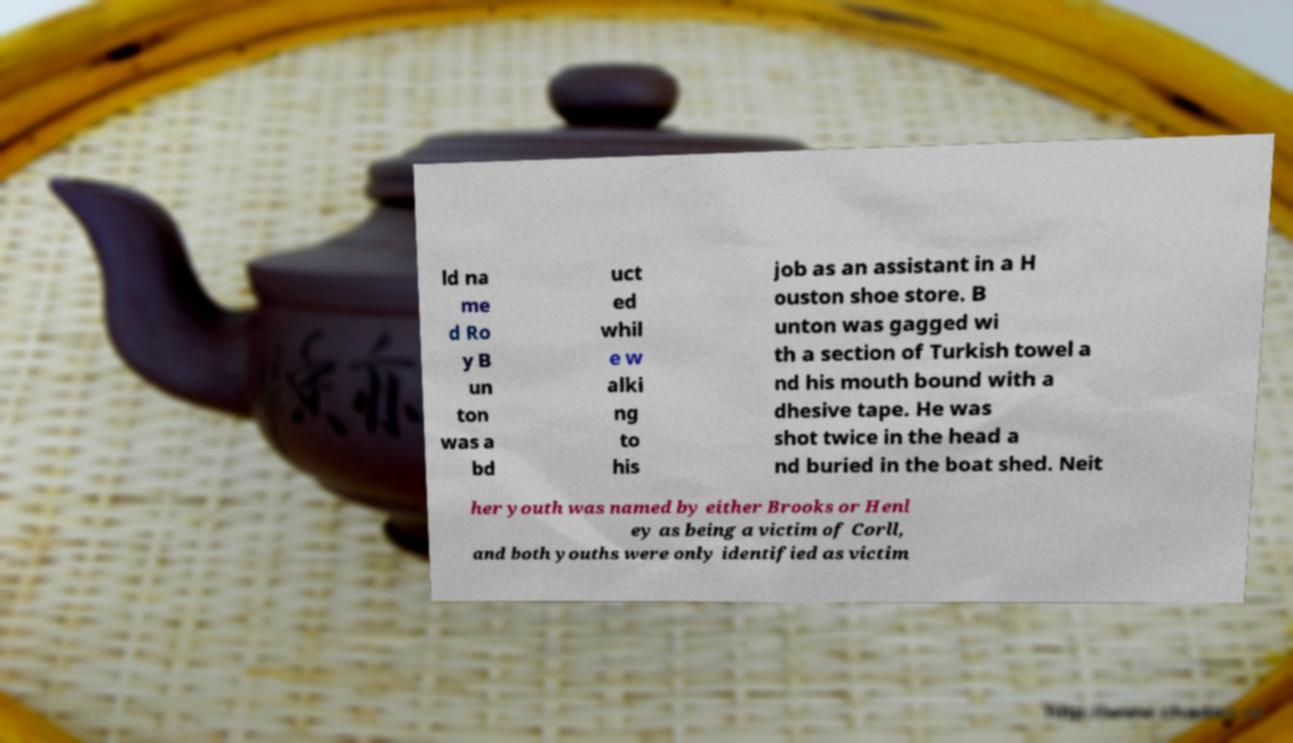Can you read and provide the text displayed in the image?This photo seems to have some interesting text. Can you extract and type it out for me? ld na me d Ro y B un ton was a bd uct ed whil e w alki ng to his job as an assistant in a H ouston shoe store. B unton was gagged wi th a section of Turkish towel a nd his mouth bound with a dhesive tape. He was shot twice in the head a nd buried in the boat shed. Neit her youth was named by either Brooks or Henl ey as being a victim of Corll, and both youths were only identified as victim 